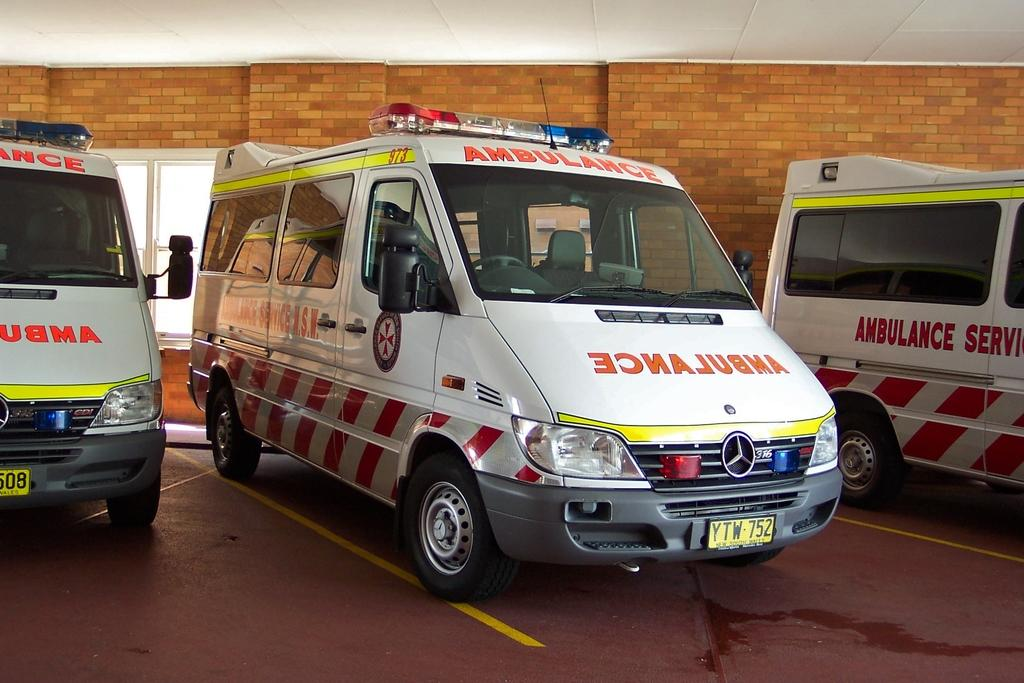What is the main subject of the image? The main subject of the image is an ambulance. What color is the ambulance? The ambulance is white. What else can be seen in the image besides the ambulance? There is a brick wall in the image. How many roots can be seen growing from the ambulance in the image? There are no roots growing from the ambulance in the image. What type of calculator is visible on the brick wall in the image? There is no calculator present in the image. 